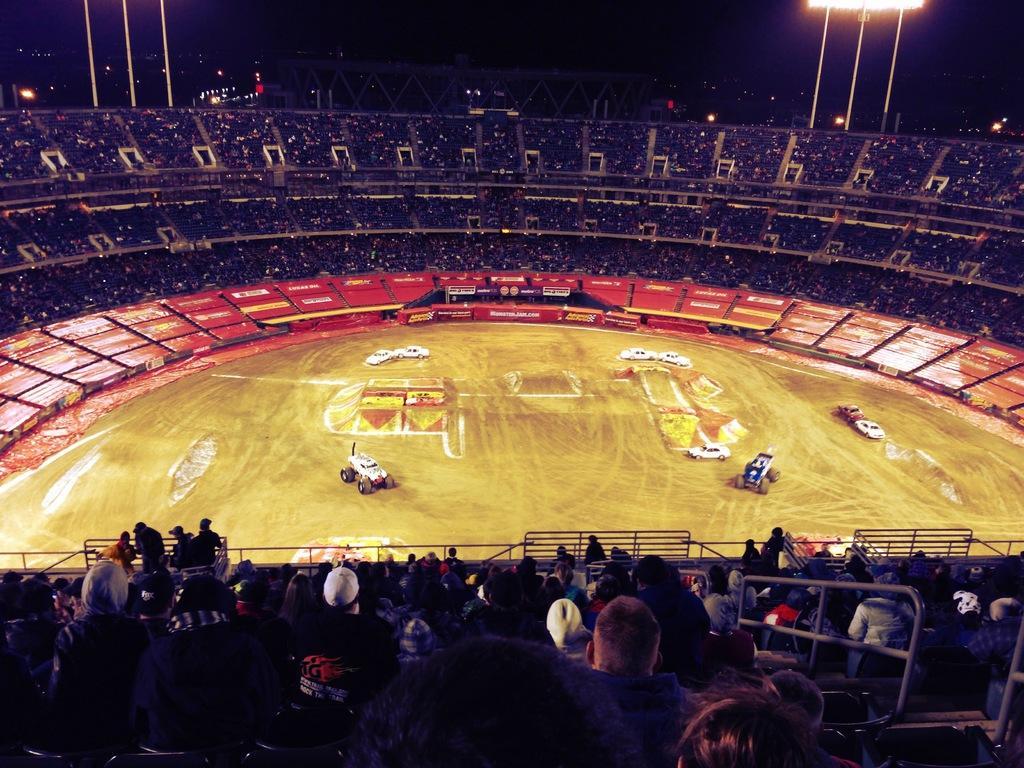In one or two sentences, can you explain what this image depicts? In this image I can see few persons sitting in the stadium, the railing, the ground, few cars on the ground and the stadium. I can see few light poles, few lights and the dark sky in the background. 